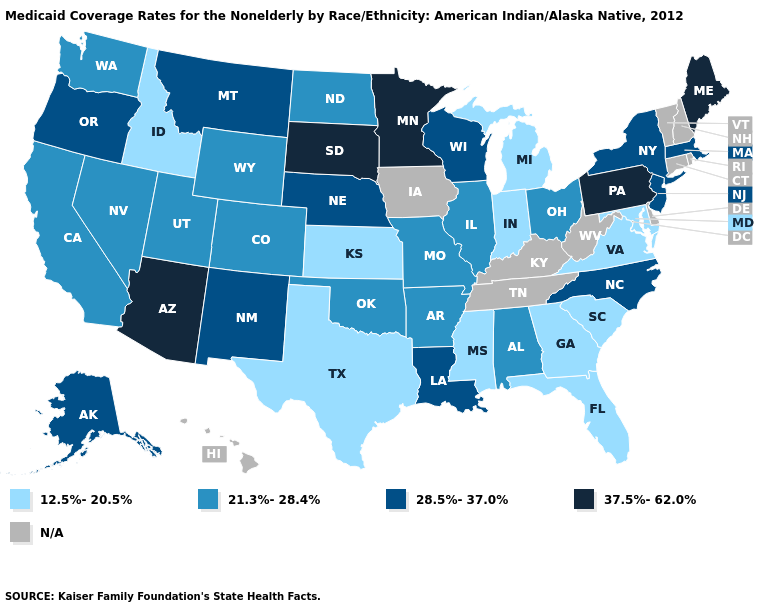What is the lowest value in states that border New Mexico?
Be succinct. 12.5%-20.5%. What is the highest value in the South ?
Give a very brief answer. 28.5%-37.0%. Does the map have missing data?
Give a very brief answer. Yes. What is the lowest value in the USA?
Quick response, please. 12.5%-20.5%. Does the map have missing data?
Write a very short answer. Yes. What is the value of West Virginia?
Be succinct. N/A. Name the states that have a value in the range 12.5%-20.5%?
Be succinct. Florida, Georgia, Idaho, Indiana, Kansas, Maryland, Michigan, Mississippi, South Carolina, Texas, Virginia. Name the states that have a value in the range N/A?
Short answer required. Connecticut, Delaware, Hawaii, Iowa, Kentucky, New Hampshire, Rhode Island, Tennessee, Vermont, West Virginia. Name the states that have a value in the range 37.5%-62.0%?
Write a very short answer. Arizona, Maine, Minnesota, Pennsylvania, South Dakota. What is the highest value in the West ?
Concise answer only. 37.5%-62.0%. Which states hav the highest value in the West?
Keep it brief. Arizona. Name the states that have a value in the range 21.3%-28.4%?
Answer briefly. Alabama, Arkansas, California, Colorado, Illinois, Missouri, Nevada, North Dakota, Ohio, Oklahoma, Utah, Washington, Wyoming. Does Mississippi have the lowest value in the USA?
Short answer required. Yes. 